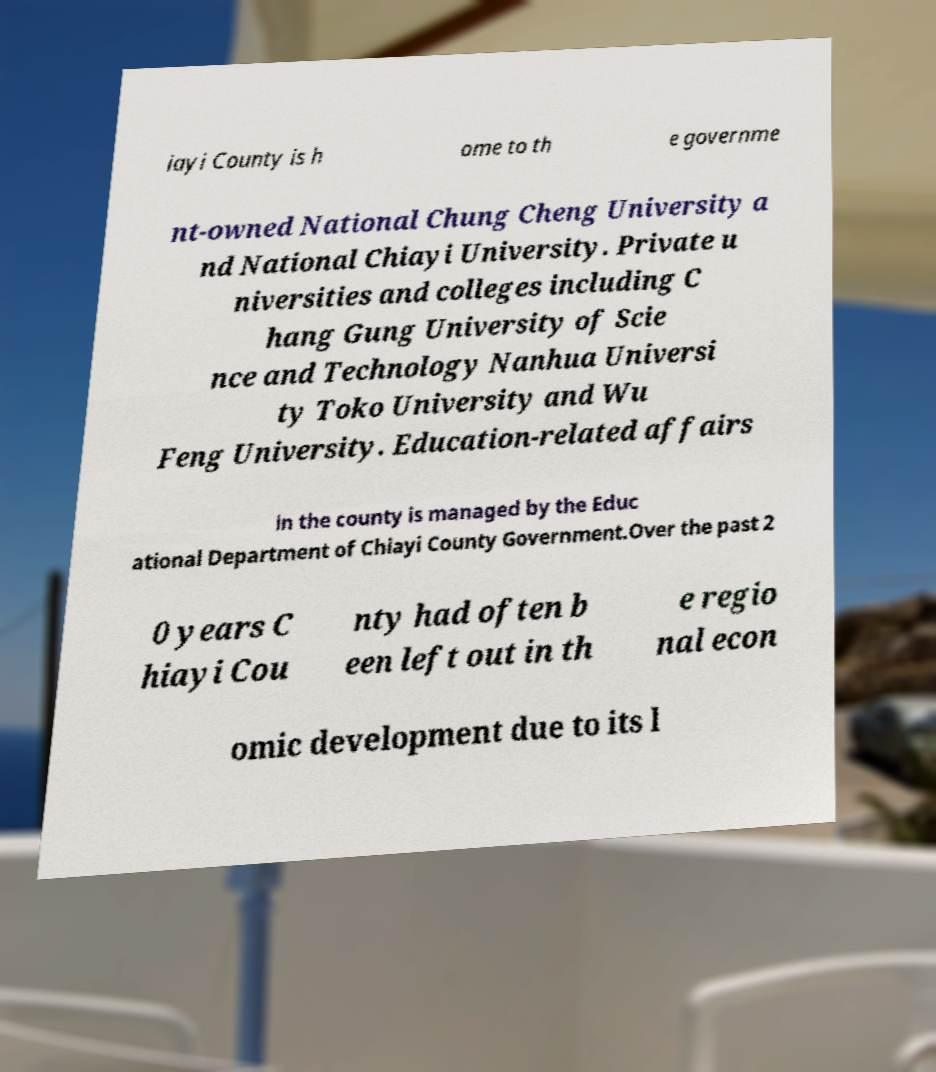Please identify and transcribe the text found in this image. iayi County is h ome to th e governme nt-owned National Chung Cheng University a nd National Chiayi University. Private u niversities and colleges including C hang Gung University of Scie nce and Technology Nanhua Universi ty Toko University and Wu Feng University. Education-related affairs in the county is managed by the Educ ational Department of Chiayi County Government.Over the past 2 0 years C hiayi Cou nty had often b een left out in th e regio nal econ omic development due to its l 